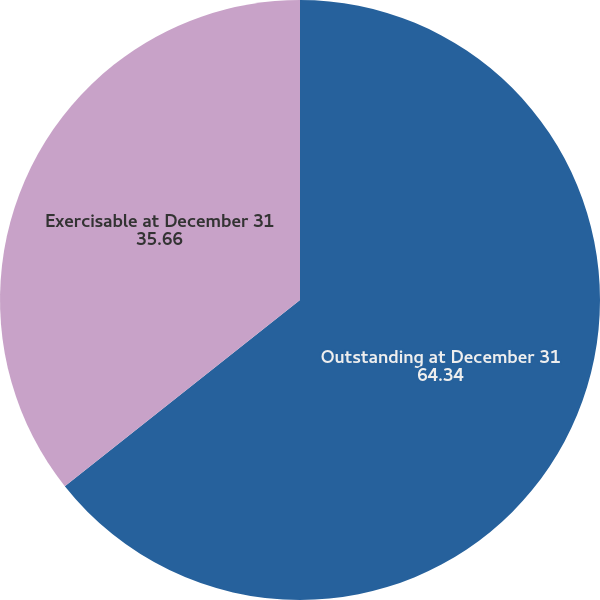Convert chart to OTSL. <chart><loc_0><loc_0><loc_500><loc_500><pie_chart><fcel>Outstanding at December 31<fcel>Exercisable at December 31<nl><fcel>64.34%<fcel>35.66%<nl></chart> 